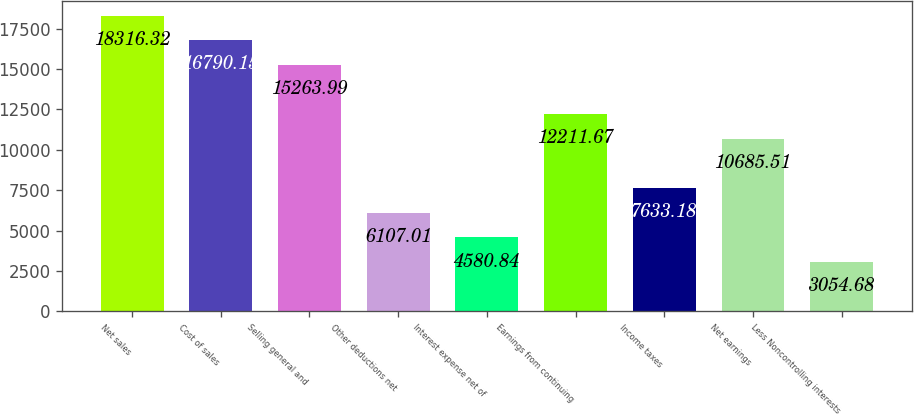Convert chart. <chart><loc_0><loc_0><loc_500><loc_500><bar_chart><fcel>Net sales<fcel>Cost of sales<fcel>Selling general and<fcel>Other deductions net<fcel>Interest expense net of<fcel>Earnings from continuing<fcel>Income taxes<fcel>Net earnings<fcel>Less Noncontrolling interests<nl><fcel>18316.3<fcel>16790.2<fcel>15264<fcel>6107.01<fcel>4580.84<fcel>12211.7<fcel>7633.18<fcel>10685.5<fcel>3054.68<nl></chart> 